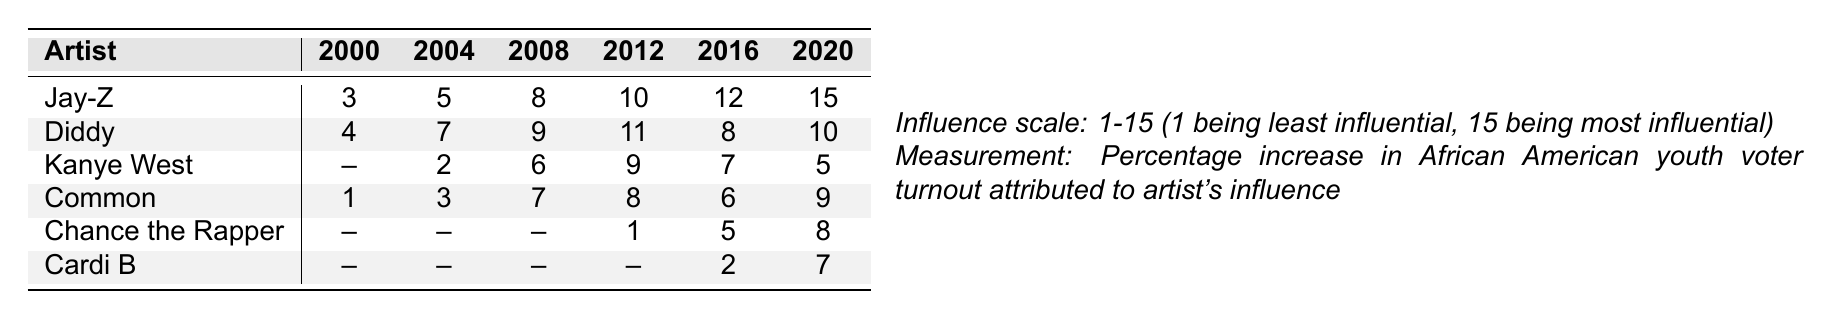What was Jay-Z's influence rating in 2008? According to the table, Jay-Z's influence rating in 2008 was 8.
Answer: 8 Which artist had the lowest influence rating in 2000? The table shows that Common had the lowest influence rating in 2000, which was 1.
Answer: Common In which year did Kanye West have the highest influence rating? Kanye West's highest influence rating was 9 in 2012.
Answer: 2012 What is the difference between Jay-Z's influence in 2020 and Diddy's influence in 2020? Jay-Z had an influence rating of 15 in 2020 and Diddy had a rating of 10. The difference is 15 - 10 = 5.
Answer: 5 What was the average influence rating for Chance the Rapper over the years he was listed? Chance the Rapper has influence ratings of 1, 5, and 8. Summing these gives 1 + 5 + 8 = 14. There are 3 ratings; therefore, the average is 14 / 3 = 4.67.
Answer: 4.67 Did Cardi B have any influence ratings before 2016? The table indicates that Cardi B has no influence ratings listed before 2016, meaning the statement is true.
Answer: No What was the trend in influence ratings for Diddy from 2000 to 2016? Diddy’s influence ratings were: 4 (2000), 7 (2004), 9 (2008), 11 (2012), and 8 (2016). The trend shows an increase until 2012, followed by a slight decrease by 2016.
Answer: Increase then decrease Which artist showed increasing influence ratings every year from 2000 to 2020? The table demonstrates that Jay-Z's influence ratings increased each year from 2000 (3) to 2020 (15), showing consistent growth.
Answer: Jay-Z How did Chance the Rapper's ratings compare between 2016 and 2020? Chance the Rapper had ratings of 5 in 2016 and 8 in 2020. Comparing these, he had an increase of 3 ratings from 2016 to 2020.
Answer: Increase of 3 If you average the ratings for Kanye West, what is the result? Kanye West had influence ratings of 2 (2004), 6 (2008), 9 (2012), 7 (2016), and 5 (2020). The sum is 2 + 6 + 9 + 7 + 5 = 29. There are 5 ratings, leading to an average of 29 / 5 = 5.8.
Answer: 5.8 